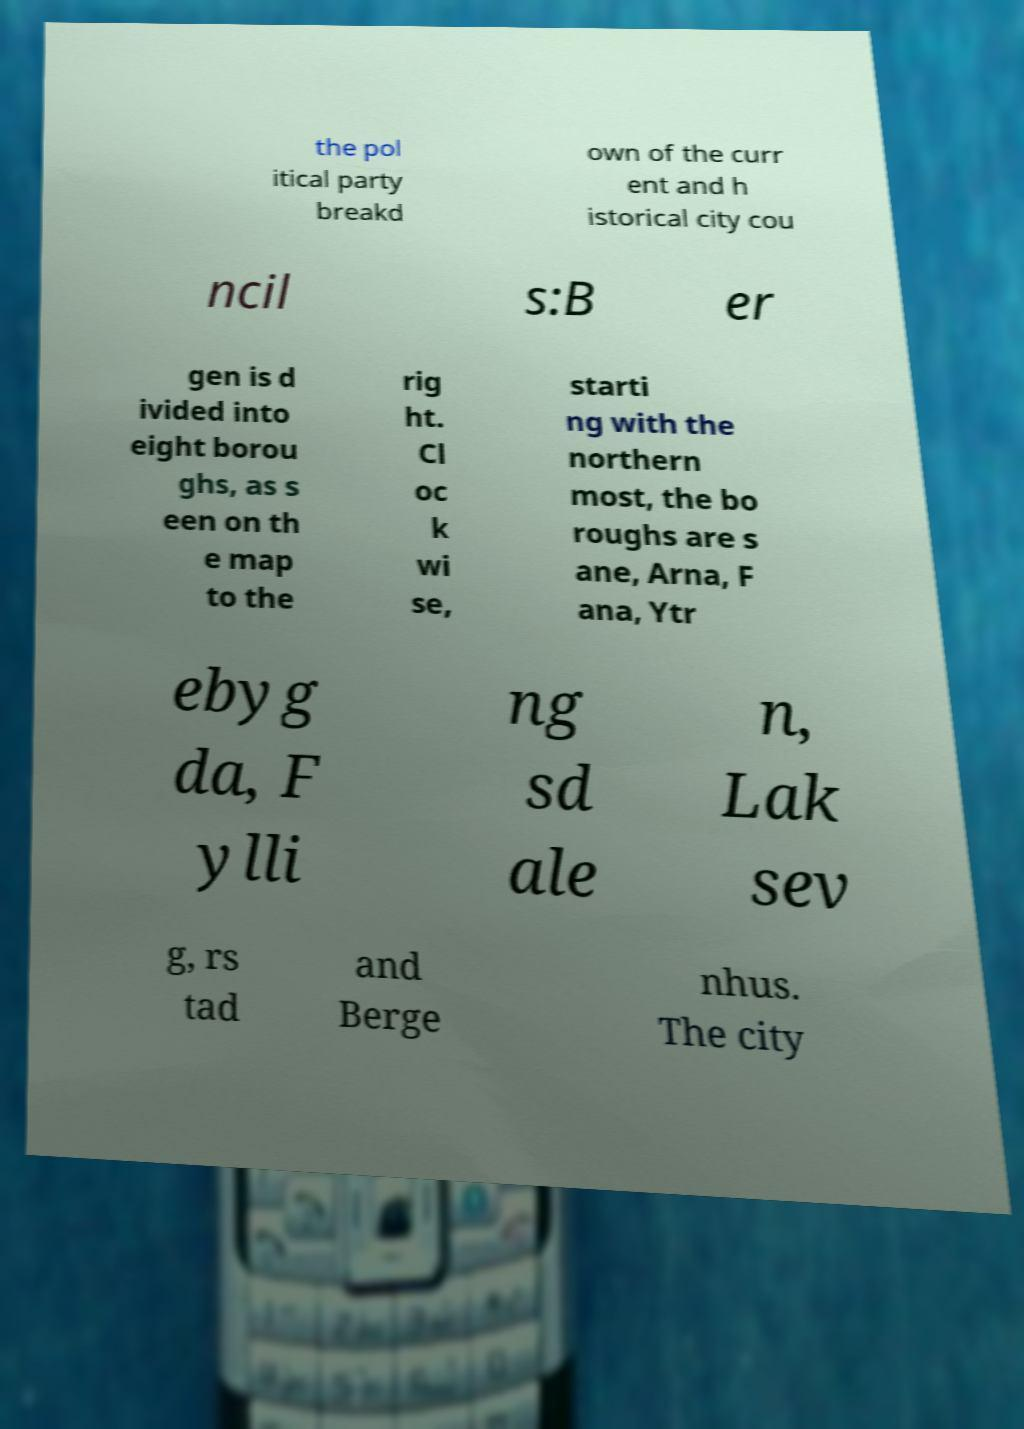Could you extract and type out the text from this image? the pol itical party breakd own of the curr ent and h istorical city cou ncil s:B er gen is d ivided into eight borou ghs, as s een on th e map to the rig ht. Cl oc k wi se, starti ng with the northern most, the bo roughs are s ane, Arna, F ana, Ytr ebyg da, F ylli ng sd ale n, Lak sev g, rs tad and Berge nhus. The city 